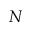Convert formula to latex. <formula><loc_0><loc_0><loc_500><loc_500>N</formula> 